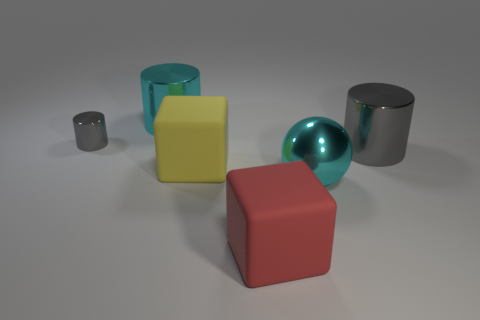What material is the cylinder that is the same color as the small object?
Provide a short and direct response. Metal. How many large yellow blocks have the same material as the big cyan ball?
Your answer should be very brief. 0. Do the cylinder on the right side of the cyan cylinder and the tiny thing have the same color?
Offer a very short reply. Yes. How many large red matte things are the same shape as the small gray metallic object?
Your answer should be compact. 0. Are there the same number of big metal cylinders left of the tiny gray shiny cylinder and large green metallic cylinders?
Provide a succinct answer. Yes. There is another rubber object that is the same size as the yellow object; what color is it?
Provide a short and direct response. Red. Are there any big yellow objects that have the same shape as the small gray object?
Your answer should be compact. No. The big cylinder in front of the object that is behind the gray cylinder that is on the left side of the big cyan cylinder is made of what material?
Your answer should be compact. Metal. What number of other objects are there of the same size as the yellow rubber cube?
Offer a very short reply. 4. The sphere has what color?
Your answer should be compact. Cyan. 